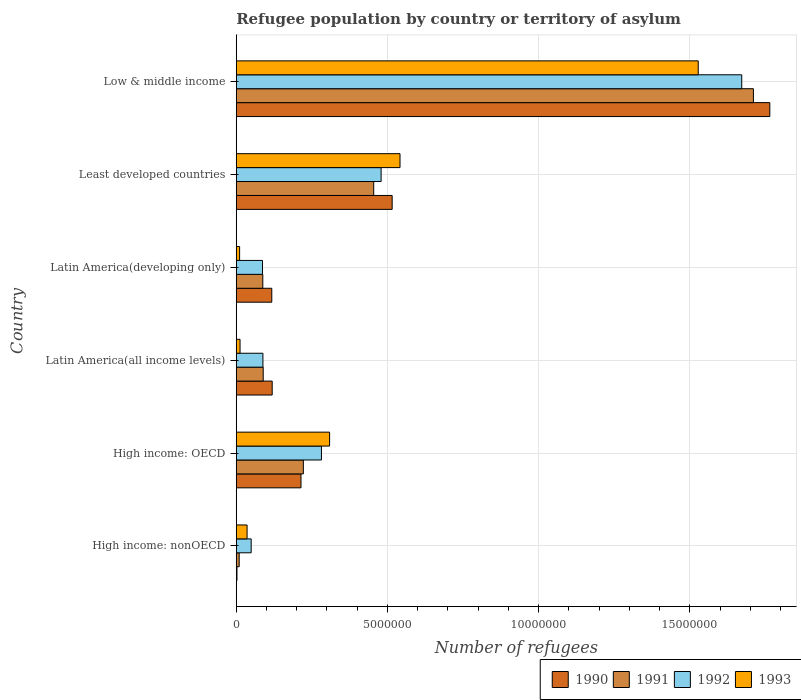How many different coloured bars are there?
Keep it short and to the point. 4. How many groups of bars are there?
Give a very brief answer. 6. Are the number of bars on each tick of the Y-axis equal?
Provide a short and direct response. Yes. What is the label of the 5th group of bars from the top?
Keep it short and to the point. High income: OECD. In how many cases, is the number of bars for a given country not equal to the number of legend labels?
Your answer should be very brief. 0. What is the number of refugees in 1993 in Latin America(all income levels)?
Offer a very short reply. 1.25e+05. Across all countries, what is the maximum number of refugees in 1991?
Your answer should be compact. 1.71e+07. Across all countries, what is the minimum number of refugees in 1990?
Provide a succinct answer. 2.39e+04. In which country was the number of refugees in 1990 minimum?
Ensure brevity in your answer.  High income: nonOECD. What is the total number of refugees in 1990 in the graph?
Provide a succinct answer. 2.73e+07. What is the difference between the number of refugees in 1992 in High income: OECD and that in Least developed countries?
Your response must be concise. -1.97e+06. What is the difference between the number of refugees in 1991 in Latin America(all income levels) and the number of refugees in 1990 in High income: OECD?
Your answer should be compact. -1.25e+06. What is the average number of refugees in 1993 per country?
Provide a short and direct response. 4.06e+06. What is the difference between the number of refugees in 1991 and number of refugees in 1992 in Latin America(developing only)?
Give a very brief answer. 1.01e+04. What is the ratio of the number of refugees in 1993 in Latin America(all income levels) to that in Low & middle income?
Provide a short and direct response. 0.01. What is the difference between the highest and the second highest number of refugees in 1993?
Your response must be concise. 9.86e+06. What is the difference between the highest and the lowest number of refugees in 1992?
Your answer should be compact. 1.62e+07. Is it the case that in every country, the sum of the number of refugees in 1991 and number of refugees in 1993 is greater than the sum of number of refugees in 1990 and number of refugees in 1992?
Make the answer very short. No. What does the 4th bar from the bottom in Latin America(all income levels) represents?
Your response must be concise. 1993. How many bars are there?
Offer a terse response. 24. Are all the bars in the graph horizontal?
Your answer should be very brief. Yes. What is the difference between two consecutive major ticks on the X-axis?
Offer a very short reply. 5.00e+06. Are the values on the major ticks of X-axis written in scientific E-notation?
Provide a short and direct response. No. Does the graph contain any zero values?
Keep it short and to the point. No. How many legend labels are there?
Offer a terse response. 4. How are the legend labels stacked?
Keep it short and to the point. Horizontal. What is the title of the graph?
Keep it short and to the point. Refugee population by country or territory of asylum. Does "1986" appear as one of the legend labels in the graph?
Keep it short and to the point. No. What is the label or title of the X-axis?
Your response must be concise. Number of refugees. What is the Number of refugees of 1990 in High income: nonOECD?
Your answer should be compact. 2.39e+04. What is the Number of refugees of 1991 in High income: nonOECD?
Your answer should be compact. 9.69e+04. What is the Number of refugees of 1992 in High income: nonOECD?
Offer a very short reply. 4.93e+05. What is the Number of refugees in 1993 in High income: nonOECD?
Your answer should be compact. 3.58e+05. What is the Number of refugees in 1990 in High income: OECD?
Provide a succinct answer. 2.14e+06. What is the Number of refugees of 1991 in High income: OECD?
Your answer should be very brief. 2.22e+06. What is the Number of refugees in 1992 in High income: OECD?
Your answer should be compact. 2.82e+06. What is the Number of refugees of 1993 in High income: OECD?
Your answer should be very brief. 3.09e+06. What is the Number of refugees of 1990 in Latin America(all income levels)?
Keep it short and to the point. 1.19e+06. What is the Number of refugees in 1991 in Latin America(all income levels)?
Ensure brevity in your answer.  8.91e+05. What is the Number of refugees in 1992 in Latin America(all income levels)?
Ensure brevity in your answer.  8.82e+05. What is the Number of refugees of 1993 in Latin America(all income levels)?
Provide a succinct answer. 1.25e+05. What is the Number of refugees in 1990 in Latin America(developing only)?
Make the answer very short. 1.17e+06. What is the Number of refugees of 1991 in Latin America(developing only)?
Keep it short and to the point. 8.78e+05. What is the Number of refugees in 1992 in Latin America(developing only)?
Provide a succinct answer. 8.67e+05. What is the Number of refugees of 1993 in Latin America(developing only)?
Provide a short and direct response. 1.11e+05. What is the Number of refugees in 1990 in Least developed countries?
Your response must be concise. 5.15e+06. What is the Number of refugees of 1991 in Least developed countries?
Give a very brief answer. 4.54e+06. What is the Number of refugees in 1992 in Least developed countries?
Your answer should be compact. 4.79e+06. What is the Number of refugees of 1993 in Least developed countries?
Your answer should be very brief. 5.41e+06. What is the Number of refugees in 1990 in Low & middle income?
Your answer should be very brief. 1.76e+07. What is the Number of refugees in 1991 in Low & middle income?
Ensure brevity in your answer.  1.71e+07. What is the Number of refugees of 1992 in Low & middle income?
Your answer should be compact. 1.67e+07. What is the Number of refugees of 1993 in Low & middle income?
Your answer should be compact. 1.53e+07. Across all countries, what is the maximum Number of refugees in 1990?
Your answer should be very brief. 1.76e+07. Across all countries, what is the maximum Number of refugees of 1991?
Your response must be concise. 1.71e+07. Across all countries, what is the maximum Number of refugees of 1992?
Your response must be concise. 1.67e+07. Across all countries, what is the maximum Number of refugees in 1993?
Ensure brevity in your answer.  1.53e+07. Across all countries, what is the minimum Number of refugees of 1990?
Your answer should be very brief. 2.39e+04. Across all countries, what is the minimum Number of refugees in 1991?
Make the answer very short. 9.69e+04. Across all countries, what is the minimum Number of refugees in 1992?
Provide a short and direct response. 4.93e+05. Across all countries, what is the minimum Number of refugees in 1993?
Ensure brevity in your answer.  1.11e+05. What is the total Number of refugees of 1990 in the graph?
Your answer should be very brief. 2.73e+07. What is the total Number of refugees in 1991 in the graph?
Give a very brief answer. 2.57e+07. What is the total Number of refugees in 1992 in the graph?
Offer a very short reply. 2.66e+07. What is the total Number of refugees of 1993 in the graph?
Offer a terse response. 2.44e+07. What is the difference between the Number of refugees in 1990 in High income: nonOECD and that in High income: OECD?
Give a very brief answer. -2.12e+06. What is the difference between the Number of refugees of 1991 in High income: nonOECD and that in High income: OECD?
Give a very brief answer. -2.12e+06. What is the difference between the Number of refugees of 1992 in High income: nonOECD and that in High income: OECD?
Your answer should be compact. -2.32e+06. What is the difference between the Number of refugees in 1993 in High income: nonOECD and that in High income: OECD?
Provide a short and direct response. -2.73e+06. What is the difference between the Number of refugees of 1990 in High income: nonOECD and that in Latin America(all income levels)?
Offer a very short reply. -1.16e+06. What is the difference between the Number of refugees in 1991 in High income: nonOECD and that in Latin America(all income levels)?
Ensure brevity in your answer.  -7.94e+05. What is the difference between the Number of refugees in 1992 in High income: nonOECD and that in Latin America(all income levels)?
Ensure brevity in your answer.  -3.88e+05. What is the difference between the Number of refugees of 1993 in High income: nonOECD and that in Latin America(all income levels)?
Your answer should be very brief. 2.33e+05. What is the difference between the Number of refugees in 1990 in High income: nonOECD and that in Latin America(developing only)?
Provide a succinct answer. -1.15e+06. What is the difference between the Number of refugees of 1991 in High income: nonOECD and that in Latin America(developing only)?
Your answer should be compact. -7.81e+05. What is the difference between the Number of refugees in 1992 in High income: nonOECD and that in Latin America(developing only)?
Keep it short and to the point. -3.74e+05. What is the difference between the Number of refugees of 1993 in High income: nonOECD and that in Latin America(developing only)?
Your answer should be very brief. 2.47e+05. What is the difference between the Number of refugees in 1990 in High income: nonOECD and that in Least developed countries?
Keep it short and to the point. -5.13e+06. What is the difference between the Number of refugees of 1991 in High income: nonOECD and that in Least developed countries?
Offer a very short reply. -4.45e+06. What is the difference between the Number of refugees in 1992 in High income: nonOECD and that in Least developed countries?
Make the answer very short. -4.30e+06. What is the difference between the Number of refugees in 1993 in High income: nonOECD and that in Least developed countries?
Provide a succinct answer. -5.06e+06. What is the difference between the Number of refugees in 1990 in High income: nonOECD and that in Low & middle income?
Give a very brief answer. -1.76e+07. What is the difference between the Number of refugees in 1991 in High income: nonOECD and that in Low & middle income?
Offer a terse response. -1.70e+07. What is the difference between the Number of refugees in 1992 in High income: nonOECD and that in Low & middle income?
Your answer should be compact. -1.62e+07. What is the difference between the Number of refugees in 1993 in High income: nonOECD and that in Low & middle income?
Provide a short and direct response. -1.49e+07. What is the difference between the Number of refugees of 1990 in High income: OECD and that in Latin America(all income levels)?
Your answer should be compact. 9.52e+05. What is the difference between the Number of refugees of 1991 in High income: OECD and that in Latin America(all income levels)?
Give a very brief answer. 1.33e+06. What is the difference between the Number of refugees in 1992 in High income: OECD and that in Latin America(all income levels)?
Your response must be concise. 1.94e+06. What is the difference between the Number of refugees in 1993 in High income: OECD and that in Latin America(all income levels)?
Give a very brief answer. 2.96e+06. What is the difference between the Number of refugees in 1990 in High income: OECD and that in Latin America(developing only)?
Offer a very short reply. 9.66e+05. What is the difference between the Number of refugees of 1991 in High income: OECD and that in Latin America(developing only)?
Give a very brief answer. 1.34e+06. What is the difference between the Number of refugees of 1992 in High income: OECD and that in Latin America(developing only)?
Keep it short and to the point. 1.95e+06. What is the difference between the Number of refugees of 1993 in High income: OECD and that in Latin America(developing only)?
Offer a terse response. 2.98e+06. What is the difference between the Number of refugees of 1990 in High income: OECD and that in Least developed countries?
Keep it short and to the point. -3.01e+06. What is the difference between the Number of refugees of 1991 in High income: OECD and that in Least developed countries?
Your response must be concise. -2.33e+06. What is the difference between the Number of refugees in 1992 in High income: OECD and that in Least developed countries?
Ensure brevity in your answer.  -1.97e+06. What is the difference between the Number of refugees of 1993 in High income: OECD and that in Least developed countries?
Your answer should be very brief. -2.33e+06. What is the difference between the Number of refugees of 1990 in High income: OECD and that in Low & middle income?
Your answer should be compact. -1.55e+07. What is the difference between the Number of refugees of 1991 in High income: OECD and that in Low & middle income?
Your response must be concise. -1.49e+07. What is the difference between the Number of refugees in 1992 in High income: OECD and that in Low & middle income?
Ensure brevity in your answer.  -1.39e+07. What is the difference between the Number of refugees of 1993 in High income: OECD and that in Low & middle income?
Your answer should be compact. -1.22e+07. What is the difference between the Number of refugees in 1990 in Latin America(all income levels) and that in Latin America(developing only)?
Offer a terse response. 1.36e+04. What is the difference between the Number of refugees of 1991 in Latin America(all income levels) and that in Latin America(developing only)?
Your response must be concise. 1.34e+04. What is the difference between the Number of refugees of 1992 in Latin America(all income levels) and that in Latin America(developing only)?
Keep it short and to the point. 1.41e+04. What is the difference between the Number of refugees of 1993 in Latin America(all income levels) and that in Latin America(developing only)?
Provide a succinct answer. 1.43e+04. What is the difference between the Number of refugees of 1990 in Latin America(all income levels) and that in Least developed countries?
Ensure brevity in your answer.  -3.97e+06. What is the difference between the Number of refugees of 1991 in Latin America(all income levels) and that in Least developed countries?
Your answer should be very brief. -3.65e+06. What is the difference between the Number of refugees of 1992 in Latin America(all income levels) and that in Least developed countries?
Your answer should be compact. -3.91e+06. What is the difference between the Number of refugees in 1993 in Latin America(all income levels) and that in Least developed countries?
Keep it short and to the point. -5.29e+06. What is the difference between the Number of refugees of 1990 in Latin America(all income levels) and that in Low & middle income?
Offer a very short reply. -1.65e+07. What is the difference between the Number of refugees in 1991 in Latin America(all income levels) and that in Low & middle income?
Offer a very short reply. -1.62e+07. What is the difference between the Number of refugees in 1992 in Latin America(all income levels) and that in Low & middle income?
Your answer should be very brief. -1.58e+07. What is the difference between the Number of refugees in 1993 in Latin America(all income levels) and that in Low & middle income?
Provide a short and direct response. -1.51e+07. What is the difference between the Number of refugees of 1990 in Latin America(developing only) and that in Least developed countries?
Your response must be concise. -3.98e+06. What is the difference between the Number of refugees of 1991 in Latin America(developing only) and that in Least developed countries?
Offer a very short reply. -3.67e+06. What is the difference between the Number of refugees of 1992 in Latin America(developing only) and that in Least developed countries?
Provide a short and direct response. -3.92e+06. What is the difference between the Number of refugees in 1993 in Latin America(developing only) and that in Least developed countries?
Ensure brevity in your answer.  -5.30e+06. What is the difference between the Number of refugees in 1990 in Latin America(developing only) and that in Low & middle income?
Your answer should be very brief. -1.65e+07. What is the difference between the Number of refugees of 1991 in Latin America(developing only) and that in Low & middle income?
Your answer should be very brief. -1.62e+07. What is the difference between the Number of refugees of 1992 in Latin America(developing only) and that in Low & middle income?
Provide a succinct answer. -1.58e+07. What is the difference between the Number of refugees of 1993 in Latin America(developing only) and that in Low & middle income?
Provide a short and direct response. -1.52e+07. What is the difference between the Number of refugees of 1990 in Least developed countries and that in Low & middle income?
Provide a short and direct response. -1.25e+07. What is the difference between the Number of refugees in 1991 in Least developed countries and that in Low & middle income?
Ensure brevity in your answer.  -1.26e+07. What is the difference between the Number of refugees in 1992 in Least developed countries and that in Low & middle income?
Offer a terse response. -1.19e+07. What is the difference between the Number of refugees of 1993 in Least developed countries and that in Low & middle income?
Your answer should be very brief. -9.86e+06. What is the difference between the Number of refugees of 1990 in High income: nonOECD and the Number of refugees of 1991 in High income: OECD?
Offer a terse response. -2.19e+06. What is the difference between the Number of refugees in 1990 in High income: nonOECD and the Number of refugees in 1992 in High income: OECD?
Make the answer very short. -2.79e+06. What is the difference between the Number of refugees in 1990 in High income: nonOECD and the Number of refugees in 1993 in High income: OECD?
Provide a succinct answer. -3.06e+06. What is the difference between the Number of refugees in 1991 in High income: nonOECD and the Number of refugees in 1992 in High income: OECD?
Ensure brevity in your answer.  -2.72e+06. What is the difference between the Number of refugees of 1991 in High income: nonOECD and the Number of refugees of 1993 in High income: OECD?
Your response must be concise. -2.99e+06. What is the difference between the Number of refugees of 1992 in High income: nonOECD and the Number of refugees of 1993 in High income: OECD?
Provide a short and direct response. -2.59e+06. What is the difference between the Number of refugees of 1990 in High income: nonOECD and the Number of refugees of 1991 in Latin America(all income levels)?
Keep it short and to the point. -8.67e+05. What is the difference between the Number of refugees in 1990 in High income: nonOECD and the Number of refugees in 1992 in Latin America(all income levels)?
Make the answer very short. -8.58e+05. What is the difference between the Number of refugees of 1990 in High income: nonOECD and the Number of refugees of 1993 in Latin America(all income levels)?
Ensure brevity in your answer.  -1.01e+05. What is the difference between the Number of refugees of 1991 in High income: nonOECD and the Number of refugees of 1992 in Latin America(all income levels)?
Keep it short and to the point. -7.85e+05. What is the difference between the Number of refugees in 1991 in High income: nonOECD and the Number of refugees in 1993 in Latin America(all income levels)?
Offer a very short reply. -2.83e+04. What is the difference between the Number of refugees in 1992 in High income: nonOECD and the Number of refugees in 1993 in Latin America(all income levels)?
Offer a terse response. 3.68e+05. What is the difference between the Number of refugees of 1990 in High income: nonOECD and the Number of refugees of 1991 in Latin America(developing only)?
Give a very brief answer. -8.54e+05. What is the difference between the Number of refugees of 1990 in High income: nonOECD and the Number of refugees of 1992 in Latin America(developing only)?
Keep it short and to the point. -8.44e+05. What is the difference between the Number of refugees of 1990 in High income: nonOECD and the Number of refugees of 1993 in Latin America(developing only)?
Offer a terse response. -8.71e+04. What is the difference between the Number of refugees in 1991 in High income: nonOECD and the Number of refugees in 1992 in Latin America(developing only)?
Your response must be concise. -7.70e+05. What is the difference between the Number of refugees of 1991 in High income: nonOECD and the Number of refugees of 1993 in Latin America(developing only)?
Offer a very short reply. -1.41e+04. What is the difference between the Number of refugees in 1992 in High income: nonOECD and the Number of refugees in 1993 in Latin America(developing only)?
Your answer should be very brief. 3.82e+05. What is the difference between the Number of refugees in 1990 in High income: nonOECD and the Number of refugees in 1991 in Least developed countries?
Offer a terse response. -4.52e+06. What is the difference between the Number of refugees in 1990 in High income: nonOECD and the Number of refugees in 1992 in Least developed countries?
Ensure brevity in your answer.  -4.77e+06. What is the difference between the Number of refugees in 1990 in High income: nonOECD and the Number of refugees in 1993 in Least developed countries?
Make the answer very short. -5.39e+06. What is the difference between the Number of refugees of 1991 in High income: nonOECD and the Number of refugees of 1992 in Least developed countries?
Make the answer very short. -4.69e+06. What is the difference between the Number of refugees in 1991 in High income: nonOECD and the Number of refugees in 1993 in Least developed countries?
Ensure brevity in your answer.  -5.32e+06. What is the difference between the Number of refugees in 1992 in High income: nonOECD and the Number of refugees in 1993 in Least developed countries?
Provide a short and direct response. -4.92e+06. What is the difference between the Number of refugees of 1990 in High income: nonOECD and the Number of refugees of 1991 in Low & middle income?
Provide a short and direct response. -1.71e+07. What is the difference between the Number of refugees of 1990 in High income: nonOECD and the Number of refugees of 1992 in Low & middle income?
Ensure brevity in your answer.  -1.67e+07. What is the difference between the Number of refugees of 1990 in High income: nonOECD and the Number of refugees of 1993 in Low & middle income?
Your answer should be very brief. -1.53e+07. What is the difference between the Number of refugees in 1991 in High income: nonOECD and the Number of refugees in 1992 in Low & middle income?
Ensure brevity in your answer.  -1.66e+07. What is the difference between the Number of refugees in 1991 in High income: nonOECD and the Number of refugees in 1993 in Low & middle income?
Your response must be concise. -1.52e+07. What is the difference between the Number of refugees in 1992 in High income: nonOECD and the Number of refugees in 1993 in Low & middle income?
Provide a succinct answer. -1.48e+07. What is the difference between the Number of refugees of 1990 in High income: OECD and the Number of refugees of 1991 in Latin America(all income levels)?
Make the answer very short. 1.25e+06. What is the difference between the Number of refugees of 1990 in High income: OECD and the Number of refugees of 1992 in Latin America(all income levels)?
Offer a terse response. 1.26e+06. What is the difference between the Number of refugees of 1990 in High income: OECD and the Number of refugees of 1993 in Latin America(all income levels)?
Your answer should be compact. 2.02e+06. What is the difference between the Number of refugees of 1991 in High income: OECD and the Number of refugees of 1992 in Latin America(all income levels)?
Make the answer very short. 1.34e+06. What is the difference between the Number of refugees of 1991 in High income: OECD and the Number of refugees of 1993 in Latin America(all income levels)?
Provide a succinct answer. 2.09e+06. What is the difference between the Number of refugees in 1992 in High income: OECD and the Number of refugees in 1993 in Latin America(all income levels)?
Provide a succinct answer. 2.69e+06. What is the difference between the Number of refugees in 1990 in High income: OECD and the Number of refugees in 1991 in Latin America(developing only)?
Your answer should be very brief. 1.26e+06. What is the difference between the Number of refugees of 1990 in High income: OECD and the Number of refugees of 1992 in Latin America(developing only)?
Give a very brief answer. 1.27e+06. What is the difference between the Number of refugees of 1990 in High income: OECD and the Number of refugees of 1993 in Latin America(developing only)?
Provide a succinct answer. 2.03e+06. What is the difference between the Number of refugees in 1991 in High income: OECD and the Number of refugees in 1992 in Latin America(developing only)?
Your answer should be compact. 1.35e+06. What is the difference between the Number of refugees of 1991 in High income: OECD and the Number of refugees of 1993 in Latin America(developing only)?
Offer a very short reply. 2.11e+06. What is the difference between the Number of refugees in 1992 in High income: OECD and the Number of refugees in 1993 in Latin America(developing only)?
Offer a terse response. 2.71e+06. What is the difference between the Number of refugees of 1990 in High income: OECD and the Number of refugees of 1991 in Least developed countries?
Provide a short and direct response. -2.40e+06. What is the difference between the Number of refugees in 1990 in High income: OECD and the Number of refugees in 1992 in Least developed countries?
Give a very brief answer. -2.65e+06. What is the difference between the Number of refugees of 1990 in High income: OECD and the Number of refugees of 1993 in Least developed countries?
Provide a short and direct response. -3.27e+06. What is the difference between the Number of refugees of 1991 in High income: OECD and the Number of refugees of 1992 in Least developed countries?
Ensure brevity in your answer.  -2.57e+06. What is the difference between the Number of refugees in 1991 in High income: OECD and the Number of refugees in 1993 in Least developed countries?
Make the answer very short. -3.20e+06. What is the difference between the Number of refugees in 1992 in High income: OECD and the Number of refugees in 1993 in Least developed countries?
Provide a short and direct response. -2.60e+06. What is the difference between the Number of refugees in 1990 in High income: OECD and the Number of refugees in 1991 in Low & middle income?
Your answer should be very brief. -1.50e+07. What is the difference between the Number of refugees in 1990 in High income: OECD and the Number of refugees in 1992 in Low & middle income?
Give a very brief answer. -1.46e+07. What is the difference between the Number of refugees of 1990 in High income: OECD and the Number of refugees of 1993 in Low & middle income?
Offer a terse response. -1.31e+07. What is the difference between the Number of refugees of 1991 in High income: OECD and the Number of refugees of 1992 in Low & middle income?
Your response must be concise. -1.45e+07. What is the difference between the Number of refugees in 1991 in High income: OECD and the Number of refugees in 1993 in Low & middle income?
Ensure brevity in your answer.  -1.31e+07. What is the difference between the Number of refugees in 1992 in High income: OECD and the Number of refugees in 1993 in Low & middle income?
Provide a short and direct response. -1.25e+07. What is the difference between the Number of refugees in 1990 in Latin America(all income levels) and the Number of refugees in 1991 in Latin America(developing only)?
Make the answer very short. 3.11e+05. What is the difference between the Number of refugees of 1990 in Latin America(all income levels) and the Number of refugees of 1992 in Latin America(developing only)?
Provide a short and direct response. 3.21e+05. What is the difference between the Number of refugees in 1990 in Latin America(all income levels) and the Number of refugees in 1993 in Latin America(developing only)?
Offer a very short reply. 1.08e+06. What is the difference between the Number of refugees in 1991 in Latin America(all income levels) and the Number of refugees in 1992 in Latin America(developing only)?
Offer a terse response. 2.35e+04. What is the difference between the Number of refugees of 1991 in Latin America(all income levels) and the Number of refugees of 1993 in Latin America(developing only)?
Keep it short and to the point. 7.80e+05. What is the difference between the Number of refugees of 1992 in Latin America(all income levels) and the Number of refugees of 1993 in Latin America(developing only)?
Your answer should be compact. 7.71e+05. What is the difference between the Number of refugees in 1990 in Latin America(all income levels) and the Number of refugees in 1991 in Least developed countries?
Offer a very short reply. -3.36e+06. What is the difference between the Number of refugees of 1990 in Latin America(all income levels) and the Number of refugees of 1992 in Least developed countries?
Offer a very short reply. -3.60e+06. What is the difference between the Number of refugees of 1990 in Latin America(all income levels) and the Number of refugees of 1993 in Least developed countries?
Give a very brief answer. -4.23e+06. What is the difference between the Number of refugees of 1991 in Latin America(all income levels) and the Number of refugees of 1992 in Least developed countries?
Give a very brief answer. -3.90e+06. What is the difference between the Number of refugees in 1991 in Latin America(all income levels) and the Number of refugees in 1993 in Least developed countries?
Offer a very short reply. -4.52e+06. What is the difference between the Number of refugees in 1992 in Latin America(all income levels) and the Number of refugees in 1993 in Least developed countries?
Keep it short and to the point. -4.53e+06. What is the difference between the Number of refugees of 1990 in Latin America(all income levels) and the Number of refugees of 1991 in Low & middle income?
Provide a succinct answer. -1.59e+07. What is the difference between the Number of refugees of 1990 in Latin America(all income levels) and the Number of refugees of 1992 in Low & middle income?
Ensure brevity in your answer.  -1.55e+07. What is the difference between the Number of refugees of 1990 in Latin America(all income levels) and the Number of refugees of 1993 in Low & middle income?
Offer a very short reply. -1.41e+07. What is the difference between the Number of refugees of 1991 in Latin America(all income levels) and the Number of refugees of 1992 in Low & middle income?
Your answer should be very brief. -1.58e+07. What is the difference between the Number of refugees in 1991 in Latin America(all income levels) and the Number of refugees in 1993 in Low & middle income?
Ensure brevity in your answer.  -1.44e+07. What is the difference between the Number of refugees of 1992 in Latin America(all income levels) and the Number of refugees of 1993 in Low & middle income?
Provide a succinct answer. -1.44e+07. What is the difference between the Number of refugees in 1990 in Latin America(developing only) and the Number of refugees in 1991 in Least developed countries?
Offer a terse response. -3.37e+06. What is the difference between the Number of refugees of 1990 in Latin America(developing only) and the Number of refugees of 1992 in Least developed countries?
Keep it short and to the point. -3.61e+06. What is the difference between the Number of refugees in 1990 in Latin America(developing only) and the Number of refugees in 1993 in Least developed countries?
Your response must be concise. -4.24e+06. What is the difference between the Number of refugees of 1991 in Latin America(developing only) and the Number of refugees of 1992 in Least developed countries?
Provide a succinct answer. -3.91e+06. What is the difference between the Number of refugees in 1991 in Latin America(developing only) and the Number of refugees in 1993 in Least developed countries?
Provide a short and direct response. -4.54e+06. What is the difference between the Number of refugees in 1992 in Latin America(developing only) and the Number of refugees in 1993 in Least developed countries?
Provide a short and direct response. -4.55e+06. What is the difference between the Number of refugees of 1990 in Latin America(developing only) and the Number of refugees of 1991 in Low & middle income?
Your response must be concise. -1.59e+07. What is the difference between the Number of refugees in 1990 in Latin America(developing only) and the Number of refugees in 1992 in Low & middle income?
Give a very brief answer. -1.55e+07. What is the difference between the Number of refugees of 1990 in Latin America(developing only) and the Number of refugees of 1993 in Low & middle income?
Offer a very short reply. -1.41e+07. What is the difference between the Number of refugees in 1991 in Latin America(developing only) and the Number of refugees in 1992 in Low & middle income?
Provide a short and direct response. -1.58e+07. What is the difference between the Number of refugees of 1991 in Latin America(developing only) and the Number of refugees of 1993 in Low & middle income?
Provide a succinct answer. -1.44e+07. What is the difference between the Number of refugees in 1992 in Latin America(developing only) and the Number of refugees in 1993 in Low & middle income?
Make the answer very short. -1.44e+07. What is the difference between the Number of refugees of 1990 in Least developed countries and the Number of refugees of 1991 in Low & middle income?
Give a very brief answer. -1.19e+07. What is the difference between the Number of refugees in 1990 in Least developed countries and the Number of refugees in 1992 in Low & middle income?
Offer a very short reply. -1.16e+07. What is the difference between the Number of refugees in 1990 in Least developed countries and the Number of refugees in 1993 in Low & middle income?
Your response must be concise. -1.01e+07. What is the difference between the Number of refugees of 1991 in Least developed countries and the Number of refugees of 1992 in Low & middle income?
Keep it short and to the point. -1.22e+07. What is the difference between the Number of refugees of 1991 in Least developed countries and the Number of refugees of 1993 in Low & middle income?
Give a very brief answer. -1.07e+07. What is the difference between the Number of refugees of 1992 in Least developed countries and the Number of refugees of 1993 in Low & middle income?
Make the answer very short. -1.05e+07. What is the average Number of refugees in 1990 per country?
Give a very brief answer. 4.55e+06. What is the average Number of refugees in 1991 per country?
Keep it short and to the point. 4.29e+06. What is the average Number of refugees in 1992 per country?
Make the answer very short. 4.43e+06. What is the average Number of refugees of 1993 per country?
Ensure brevity in your answer.  4.06e+06. What is the difference between the Number of refugees of 1990 and Number of refugees of 1991 in High income: nonOECD?
Make the answer very short. -7.30e+04. What is the difference between the Number of refugees in 1990 and Number of refugees in 1992 in High income: nonOECD?
Provide a short and direct response. -4.69e+05. What is the difference between the Number of refugees in 1990 and Number of refugees in 1993 in High income: nonOECD?
Keep it short and to the point. -3.34e+05. What is the difference between the Number of refugees in 1991 and Number of refugees in 1992 in High income: nonOECD?
Ensure brevity in your answer.  -3.96e+05. What is the difference between the Number of refugees in 1991 and Number of refugees in 1993 in High income: nonOECD?
Your answer should be very brief. -2.61e+05. What is the difference between the Number of refugees of 1992 and Number of refugees of 1993 in High income: nonOECD?
Make the answer very short. 1.35e+05. What is the difference between the Number of refugees in 1990 and Number of refugees in 1991 in High income: OECD?
Your response must be concise. -7.80e+04. What is the difference between the Number of refugees of 1990 and Number of refugees of 1992 in High income: OECD?
Keep it short and to the point. -6.77e+05. What is the difference between the Number of refugees in 1990 and Number of refugees in 1993 in High income: OECD?
Offer a very short reply. -9.46e+05. What is the difference between the Number of refugees in 1991 and Number of refugees in 1992 in High income: OECD?
Offer a very short reply. -5.99e+05. What is the difference between the Number of refugees of 1991 and Number of refugees of 1993 in High income: OECD?
Give a very brief answer. -8.68e+05. What is the difference between the Number of refugees of 1992 and Number of refugees of 1993 in High income: OECD?
Give a very brief answer. -2.69e+05. What is the difference between the Number of refugees in 1990 and Number of refugees in 1991 in Latin America(all income levels)?
Your response must be concise. 2.97e+05. What is the difference between the Number of refugees of 1990 and Number of refugees of 1992 in Latin America(all income levels)?
Provide a succinct answer. 3.07e+05. What is the difference between the Number of refugees in 1990 and Number of refugees in 1993 in Latin America(all income levels)?
Ensure brevity in your answer.  1.06e+06. What is the difference between the Number of refugees of 1991 and Number of refugees of 1992 in Latin America(all income levels)?
Your answer should be compact. 9437. What is the difference between the Number of refugees of 1991 and Number of refugees of 1993 in Latin America(all income levels)?
Make the answer very short. 7.66e+05. What is the difference between the Number of refugees of 1992 and Number of refugees of 1993 in Latin America(all income levels)?
Your answer should be very brief. 7.56e+05. What is the difference between the Number of refugees of 1990 and Number of refugees of 1991 in Latin America(developing only)?
Provide a succinct answer. 2.97e+05. What is the difference between the Number of refugees of 1990 and Number of refugees of 1992 in Latin America(developing only)?
Make the answer very short. 3.07e+05. What is the difference between the Number of refugees in 1990 and Number of refugees in 1993 in Latin America(developing only)?
Ensure brevity in your answer.  1.06e+06. What is the difference between the Number of refugees in 1991 and Number of refugees in 1992 in Latin America(developing only)?
Keep it short and to the point. 1.01e+04. What is the difference between the Number of refugees of 1991 and Number of refugees of 1993 in Latin America(developing only)?
Offer a very short reply. 7.67e+05. What is the difference between the Number of refugees in 1992 and Number of refugees in 1993 in Latin America(developing only)?
Offer a very short reply. 7.56e+05. What is the difference between the Number of refugees of 1990 and Number of refugees of 1991 in Least developed countries?
Offer a terse response. 6.10e+05. What is the difference between the Number of refugees in 1990 and Number of refugees in 1992 in Least developed countries?
Keep it short and to the point. 3.65e+05. What is the difference between the Number of refugees in 1990 and Number of refugees in 1993 in Least developed countries?
Offer a very short reply. -2.60e+05. What is the difference between the Number of refugees in 1991 and Number of refugees in 1992 in Least developed countries?
Ensure brevity in your answer.  -2.45e+05. What is the difference between the Number of refugees of 1991 and Number of refugees of 1993 in Least developed countries?
Offer a very short reply. -8.70e+05. What is the difference between the Number of refugees of 1992 and Number of refugees of 1993 in Least developed countries?
Your response must be concise. -6.25e+05. What is the difference between the Number of refugees of 1990 and Number of refugees of 1991 in Low & middle income?
Keep it short and to the point. 5.42e+05. What is the difference between the Number of refugees in 1990 and Number of refugees in 1992 in Low & middle income?
Offer a terse response. 9.28e+05. What is the difference between the Number of refugees of 1990 and Number of refugees of 1993 in Low & middle income?
Your answer should be very brief. 2.37e+06. What is the difference between the Number of refugees of 1991 and Number of refugees of 1992 in Low & middle income?
Your answer should be compact. 3.87e+05. What is the difference between the Number of refugees of 1991 and Number of refugees of 1993 in Low & middle income?
Keep it short and to the point. 1.82e+06. What is the difference between the Number of refugees in 1992 and Number of refugees in 1993 in Low & middle income?
Keep it short and to the point. 1.44e+06. What is the ratio of the Number of refugees in 1990 in High income: nonOECD to that in High income: OECD?
Your answer should be very brief. 0.01. What is the ratio of the Number of refugees of 1991 in High income: nonOECD to that in High income: OECD?
Your answer should be very brief. 0.04. What is the ratio of the Number of refugees of 1992 in High income: nonOECD to that in High income: OECD?
Offer a very short reply. 0.18. What is the ratio of the Number of refugees of 1993 in High income: nonOECD to that in High income: OECD?
Your answer should be compact. 0.12. What is the ratio of the Number of refugees in 1990 in High income: nonOECD to that in Latin America(all income levels)?
Your answer should be very brief. 0.02. What is the ratio of the Number of refugees of 1991 in High income: nonOECD to that in Latin America(all income levels)?
Keep it short and to the point. 0.11. What is the ratio of the Number of refugees of 1992 in High income: nonOECD to that in Latin America(all income levels)?
Provide a succinct answer. 0.56. What is the ratio of the Number of refugees in 1993 in High income: nonOECD to that in Latin America(all income levels)?
Make the answer very short. 2.86. What is the ratio of the Number of refugees in 1990 in High income: nonOECD to that in Latin America(developing only)?
Your answer should be compact. 0.02. What is the ratio of the Number of refugees of 1991 in High income: nonOECD to that in Latin America(developing only)?
Your answer should be compact. 0.11. What is the ratio of the Number of refugees of 1992 in High income: nonOECD to that in Latin America(developing only)?
Provide a succinct answer. 0.57. What is the ratio of the Number of refugees of 1993 in High income: nonOECD to that in Latin America(developing only)?
Offer a very short reply. 3.23. What is the ratio of the Number of refugees in 1990 in High income: nonOECD to that in Least developed countries?
Ensure brevity in your answer.  0. What is the ratio of the Number of refugees of 1991 in High income: nonOECD to that in Least developed countries?
Provide a short and direct response. 0.02. What is the ratio of the Number of refugees in 1992 in High income: nonOECD to that in Least developed countries?
Offer a terse response. 0.1. What is the ratio of the Number of refugees of 1993 in High income: nonOECD to that in Least developed countries?
Your response must be concise. 0.07. What is the ratio of the Number of refugees of 1990 in High income: nonOECD to that in Low & middle income?
Offer a terse response. 0. What is the ratio of the Number of refugees of 1991 in High income: nonOECD to that in Low & middle income?
Give a very brief answer. 0.01. What is the ratio of the Number of refugees in 1992 in High income: nonOECD to that in Low & middle income?
Provide a succinct answer. 0.03. What is the ratio of the Number of refugees of 1993 in High income: nonOECD to that in Low & middle income?
Give a very brief answer. 0.02. What is the ratio of the Number of refugees in 1990 in High income: OECD to that in Latin America(all income levels)?
Your answer should be very brief. 1.8. What is the ratio of the Number of refugees in 1991 in High income: OECD to that in Latin America(all income levels)?
Ensure brevity in your answer.  2.49. What is the ratio of the Number of refugees in 1992 in High income: OECD to that in Latin America(all income levels)?
Keep it short and to the point. 3.2. What is the ratio of the Number of refugees of 1993 in High income: OECD to that in Latin America(all income levels)?
Your answer should be very brief. 24.64. What is the ratio of the Number of refugees of 1990 in High income: OECD to that in Latin America(developing only)?
Your response must be concise. 1.82. What is the ratio of the Number of refugees in 1991 in High income: OECD to that in Latin America(developing only)?
Your response must be concise. 2.53. What is the ratio of the Number of refugees of 1992 in High income: OECD to that in Latin America(developing only)?
Your response must be concise. 3.25. What is the ratio of the Number of refugees of 1993 in High income: OECD to that in Latin America(developing only)?
Your response must be concise. 27.81. What is the ratio of the Number of refugees in 1990 in High income: OECD to that in Least developed countries?
Give a very brief answer. 0.42. What is the ratio of the Number of refugees in 1991 in High income: OECD to that in Least developed countries?
Ensure brevity in your answer.  0.49. What is the ratio of the Number of refugees of 1992 in High income: OECD to that in Least developed countries?
Ensure brevity in your answer.  0.59. What is the ratio of the Number of refugees in 1993 in High income: OECD to that in Least developed countries?
Offer a very short reply. 0.57. What is the ratio of the Number of refugees in 1990 in High income: OECD to that in Low & middle income?
Offer a very short reply. 0.12. What is the ratio of the Number of refugees in 1991 in High income: OECD to that in Low & middle income?
Provide a short and direct response. 0.13. What is the ratio of the Number of refugees in 1992 in High income: OECD to that in Low & middle income?
Your answer should be compact. 0.17. What is the ratio of the Number of refugees in 1993 in High income: OECD to that in Low & middle income?
Provide a succinct answer. 0.2. What is the ratio of the Number of refugees of 1990 in Latin America(all income levels) to that in Latin America(developing only)?
Your answer should be very brief. 1.01. What is the ratio of the Number of refugees of 1991 in Latin America(all income levels) to that in Latin America(developing only)?
Provide a succinct answer. 1.02. What is the ratio of the Number of refugees of 1992 in Latin America(all income levels) to that in Latin America(developing only)?
Your answer should be very brief. 1.02. What is the ratio of the Number of refugees of 1993 in Latin America(all income levels) to that in Latin America(developing only)?
Make the answer very short. 1.13. What is the ratio of the Number of refugees of 1990 in Latin America(all income levels) to that in Least developed countries?
Offer a terse response. 0.23. What is the ratio of the Number of refugees of 1991 in Latin America(all income levels) to that in Least developed countries?
Offer a very short reply. 0.2. What is the ratio of the Number of refugees of 1992 in Latin America(all income levels) to that in Least developed countries?
Provide a succinct answer. 0.18. What is the ratio of the Number of refugees of 1993 in Latin America(all income levels) to that in Least developed countries?
Offer a terse response. 0.02. What is the ratio of the Number of refugees in 1990 in Latin America(all income levels) to that in Low & middle income?
Your answer should be compact. 0.07. What is the ratio of the Number of refugees in 1991 in Latin America(all income levels) to that in Low & middle income?
Offer a very short reply. 0.05. What is the ratio of the Number of refugees in 1992 in Latin America(all income levels) to that in Low & middle income?
Make the answer very short. 0.05. What is the ratio of the Number of refugees of 1993 in Latin America(all income levels) to that in Low & middle income?
Ensure brevity in your answer.  0.01. What is the ratio of the Number of refugees in 1990 in Latin America(developing only) to that in Least developed countries?
Your response must be concise. 0.23. What is the ratio of the Number of refugees of 1991 in Latin America(developing only) to that in Least developed countries?
Offer a very short reply. 0.19. What is the ratio of the Number of refugees in 1992 in Latin America(developing only) to that in Least developed countries?
Make the answer very short. 0.18. What is the ratio of the Number of refugees in 1993 in Latin America(developing only) to that in Least developed countries?
Your answer should be very brief. 0.02. What is the ratio of the Number of refugees of 1990 in Latin America(developing only) to that in Low & middle income?
Ensure brevity in your answer.  0.07. What is the ratio of the Number of refugees of 1991 in Latin America(developing only) to that in Low & middle income?
Provide a succinct answer. 0.05. What is the ratio of the Number of refugees in 1992 in Latin America(developing only) to that in Low & middle income?
Offer a very short reply. 0.05. What is the ratio of the Number of refugees of 1993 in Latin America(developing only) to that in Low & middle income?
Offer a terse response. 0.01. What is the ratio of the Number of refugees in 1990 in Least developed countries to that in Low & middle income?
Your response must be concise. 0.29. What is the ratio of the Number of refugees in 1991 in Least developed countries to that in Low & middle income?
Make the answer very short. 0.27. What is the ratio of the Number of refugees in 1992 in Least developed countries to that in Low & middle income?
Make the answer very short. 0.29. What is the ratio of the Number of refugees of 1993 in Least developed countries to that in Low & middle income?
Provide a short and direct response. 0.35. What is the difference between the highest and the second highest Number of refugees in 1990?
Your answer should be compact. 1.25e+07. What is the difference between the highest and the second highest Number of refugees in 1991?
Give a very brief answer. 1.26e+07. What is the difference between the highest and the second highest Number of refugees of 1992?
Provide a succinct answer. 1.19e+07. What is the difference between the highest and the second highest Number of refugees of 1993?
Your response must be concise. 9.86e+06. What is the difference between the highest and the lowest Number of refugees in 1990?
Ensure brevity in your answer.  1.76e+07. What is the difference between the highest and the lowest Number of refugees of 1991?
Give a very brief answer. 1.70e+07. What is the difference between the highest and the lowest Number of refugees of 1992?
Give a very brief answer. 1.62e+07. What is the difference between the highest and the lowest Number of refugees of 1993?
Offer a terse response. 1.52e+07. 